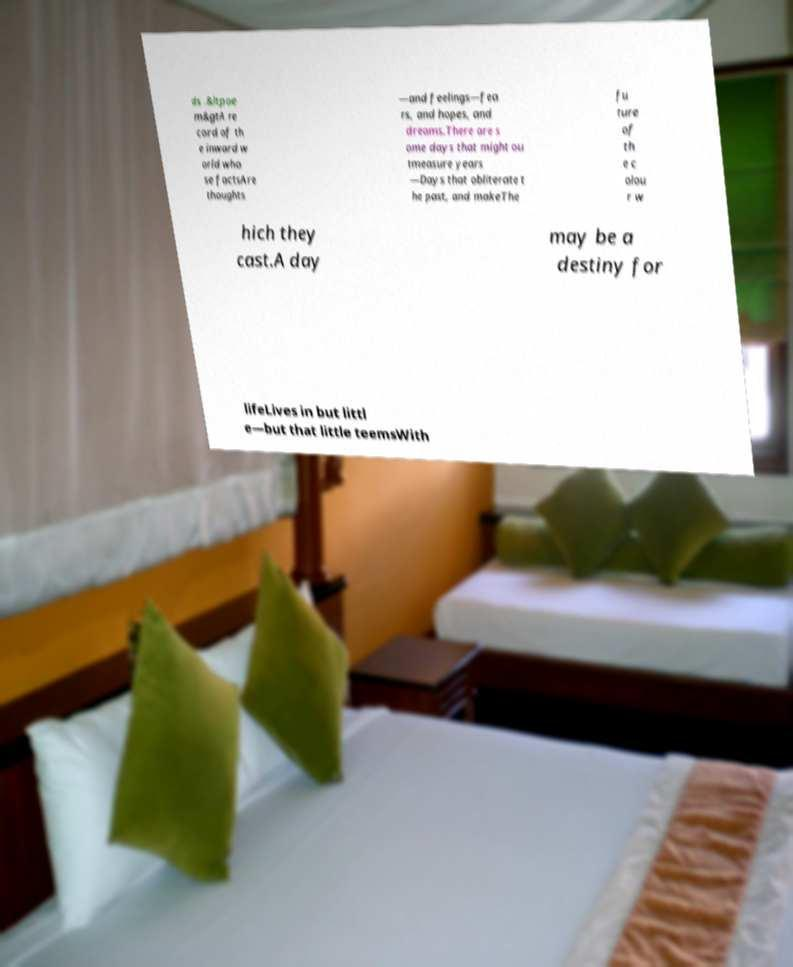Can you read and provide the text displayed in the image?This photo seems to have some interesting text. Can you extract and type it out for me? ds .&ltpoe m&gtA re cord of th e inward w orld who se factsAre thoughts —and feelings—fea rs, and hopes, and dreams.There are s ome days that might ou tmeasure years —Days that obliterate t he past, and makeThe fu ture of th e c olou r w hich they cast.A day may be a destiny for lifeLives in but littl e—but that little teemsWith 